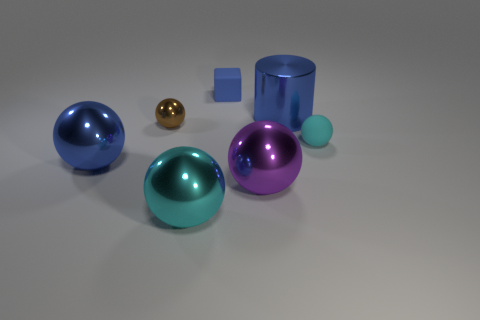Subtract all tiny rubber spheres. How many spheres are left? 4 Add 3 big brown matte blocks. How many objects exist? 10 Subtract all cubes. How many objects are left? 6 Subtract 1 cylinders. How many cylinders are left? 0 Add 5 large yellow metallic balls. How many large yellow metallic balls exist? 5 Subtract all cyan balls. How many balls are left? 3 Subtract 0 yellow balls. How many objects are left? 7 Subtract all red cylinders. Subtract all brown cubes. How many cylinders are left? 1 Subtract all gray spheres. How many gray blocks are left? 0 Subtract all big purple metallic balls. Subtract all gray metallic objects. How many objects are left? 6 